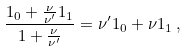Convert formula to latex. <formula><loc_0><loc_0><loc_500><loc_500>\frac { 1 _ { 0 } + \frac { \nu } { \nu ^ { \prime } } 1 _ { 1 } } { 1 + \frac { \nu } { \nu ^ { \prime } } } = \nu ^ { \prime } 1 _ { 0 } + \nu 1 _ { 1 } \, ,</formula> 